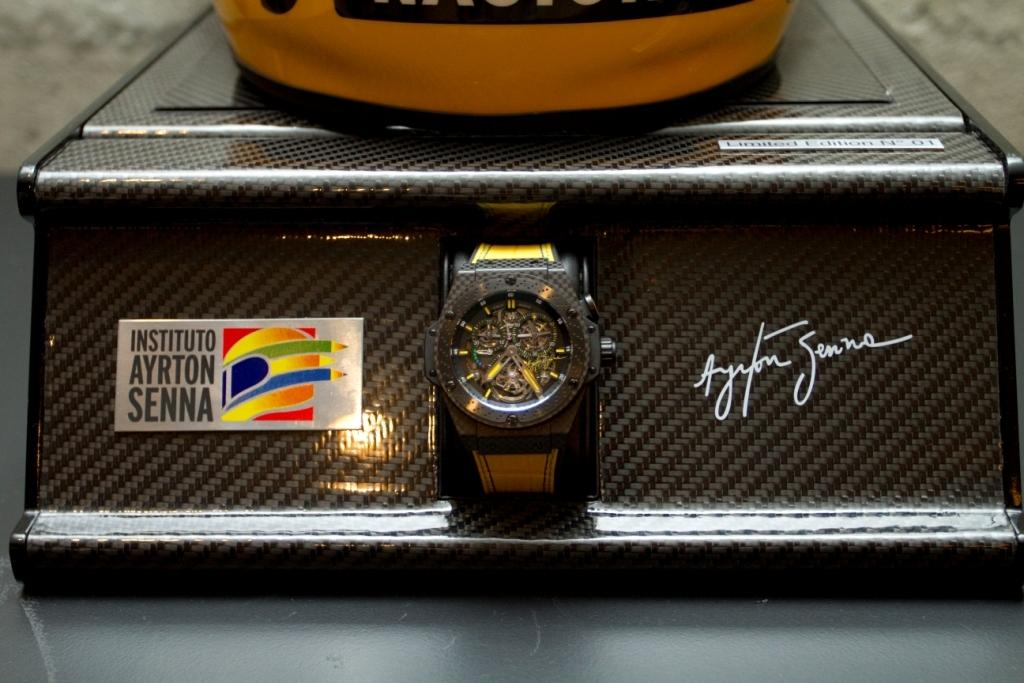<image>
Write a terse but informative summary of the picture. A watch display stand that has been signed by Senna 